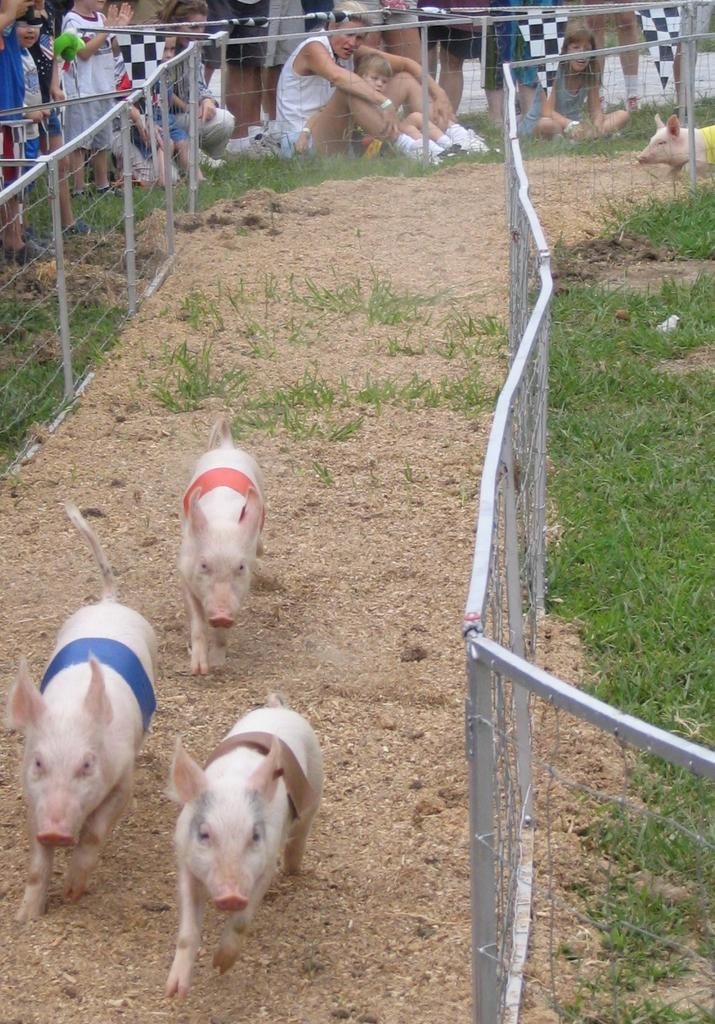How many pigs are in the image? There are three pigs in the image. What are the pigs doing in the image? The pigs are running on the sand. What can be seen on both sides of the pigs? There is a fence on both sides of the pigs. What type of vegetation is near the fence? There is grass near the fence. Who is observing the pigs in the image? People are watching the pig race behind the fence. What type of attention is the sheep receiving from the coach in the image? There is no sheep or coach present in the image; it features three pigs running on the sand with people watching behind a fence. 